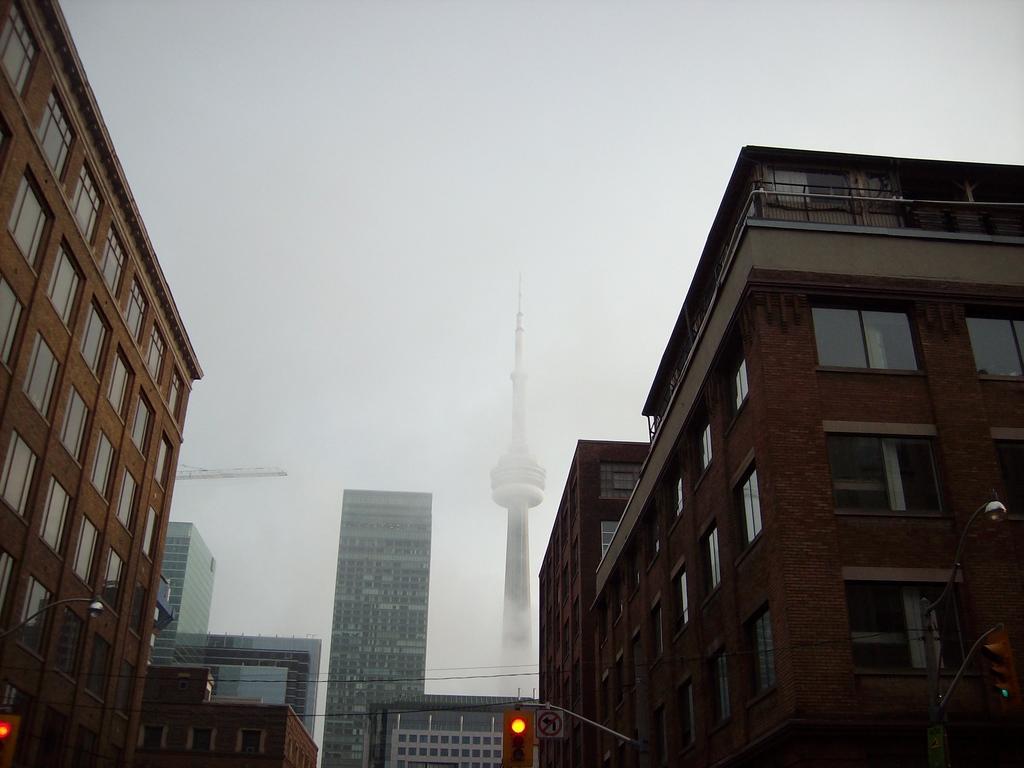Can you describe this image briefly? In this picture we can see a few traffic signals, a signboard and some buildings in the background. 